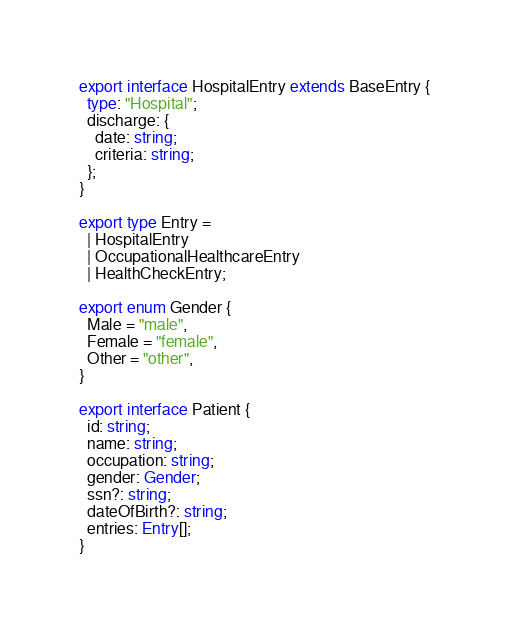Convert code to text. <code><loc_0><loc_0><loc_500><loc_500><_TypeScript_>export interface HospitalEntry extends BaseEntry {
  type: "Hospital";
  discharge: {
    date: string;
    criteria: string;
  };
}

export type Entry =
  | HospitalEntry
  | OccupationalHealthcareEntry
  | HealthCheckEntry;

export enum Gender {
  Male = "male",
  Female = "female",
  Other = "other",
}

export interface Patient {
  id: string;
  name: string;
  occupation: string;
  gender: Gender;
  ssn?: string;
  dateOfBirth?: string;
  entries: Entry[];
}
</code> 